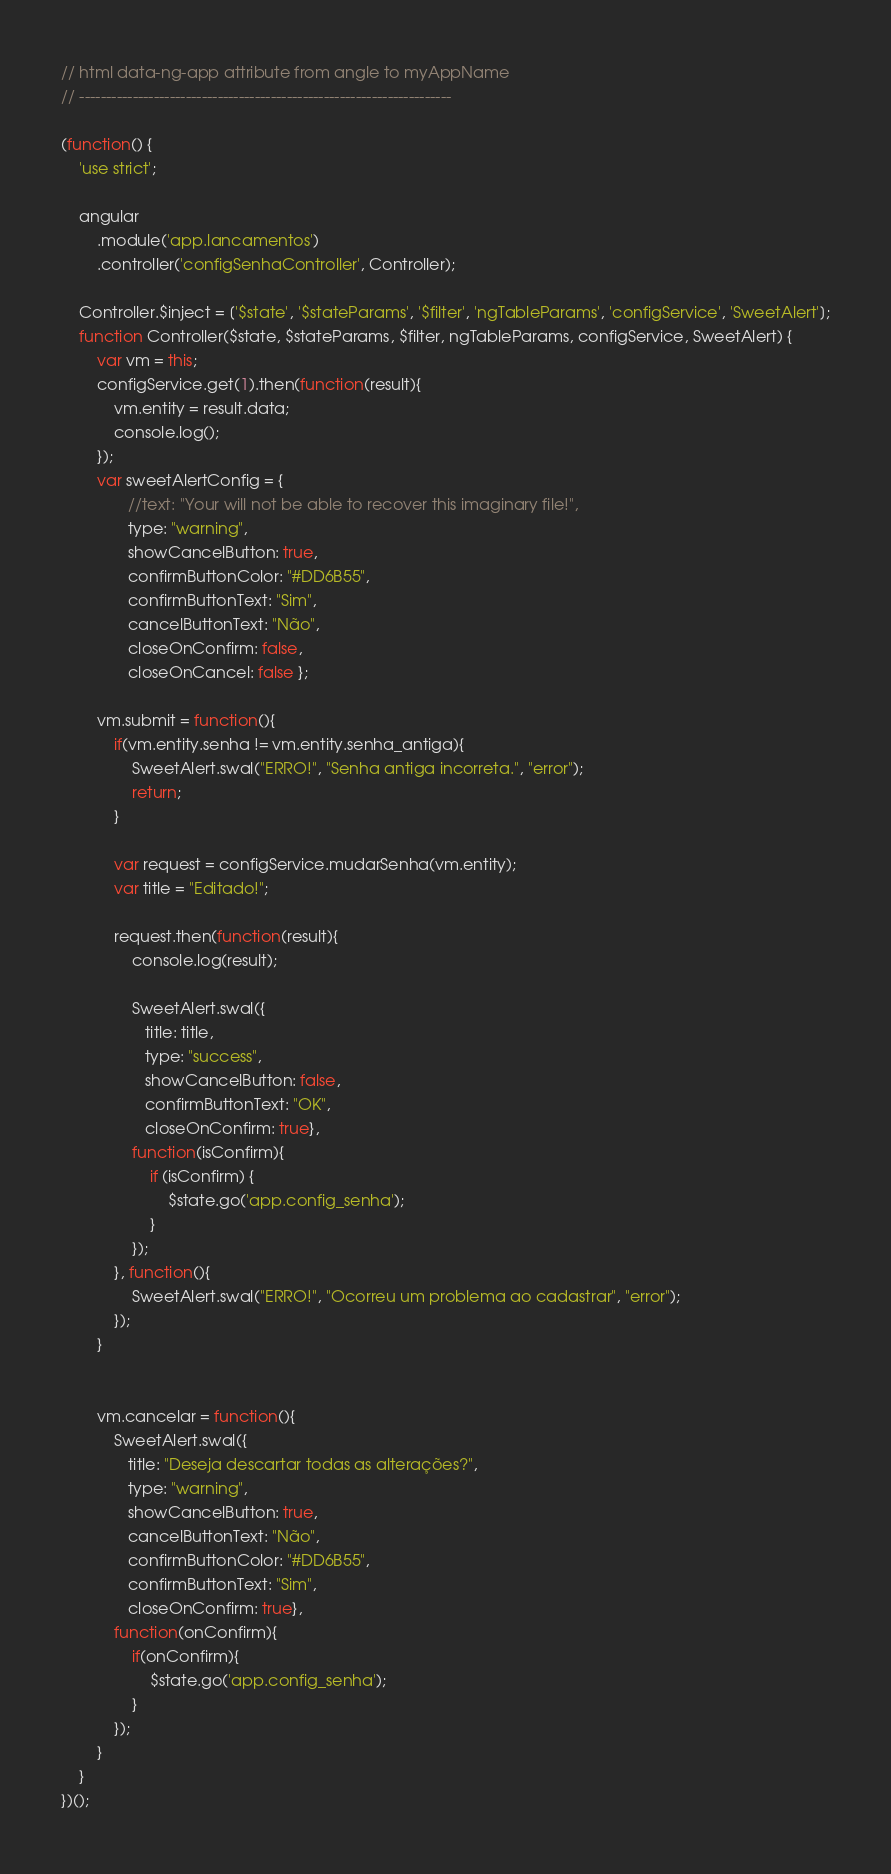Convert code to text. <code><loc_0><loc_0><loc_500><loc_500><_JavaScript_>// html data-ng-app attribute from angle to myAppName
// ----------------------------------------------------------------------

(function() {
    'use strict';

    angular
        .module('app.lancamentos')
        .controller('configSenhaController', Controller);

    Controller.$inject = ['$state', '$stateParams', '$filter', 'ngTableParams', 'configService', 'SweetAlert'];
    function Controller($state, $stateParams, $filter, ngTableParams, configService, SweetAlert) {
        var vm = this;
        configService.get(1).then(function(result){
            vm.entity = result.data;
            console.log();
        });
        var sweetAlertConfig = {
               //text: "Your will not be able to recover this imaginary file!",
               type: "warning",
               showCancelButton: true,
               confirmButtonColor: "#DD6B55",
               confirmButtonText: "Sim",
               cancelButtonText: "Não",
               closeOnConfirm: false,
               closeOnCancel: false };
               
        vm.submit = function(){
            if(vm.entity.senha != vm.entity.senha_antiga){
                SweetAlert.swal("ERRO!", "Senha antiga incorreta.", "error");
                return;
            }
            
            var request = configService.mudarSenha(vm.entity);
            var title = "Editado!";
            
            request.then(function(result){
                console.log(result);
                
                SweetAlert.swal({
                   title: title,
                   type: "success",
                   showCancelButton: false,
                   confirmButtonText: "OK",
                   closeOnConfirm: true},
                function(isConfirm){ 
                    if (isConfirm) {
                        $state.go('app.config_senha');
                    }
                });
            }, function(){
                SweetAlert.swal("ERRO!", "Ocorreu um problema ao cadastrar", "error");
            });
        }
        

        vm.cancelar = function(){
            SweetAlert.swal({
               title: "Deseja descartar todas as alterações?",
               type: "warning",
               showCancelButton: true,
               cancelButtonText: "Não",
               confirmButtonColor: "#DD6B55",
               confirmButtonText: "Sim",
               closeOnConfirm: true}, 
            function(onConfirm){ 
                if(onConfirm){
                    $state.go('app.config_senha');
                }
            });
        }
    }
})();
</code> 